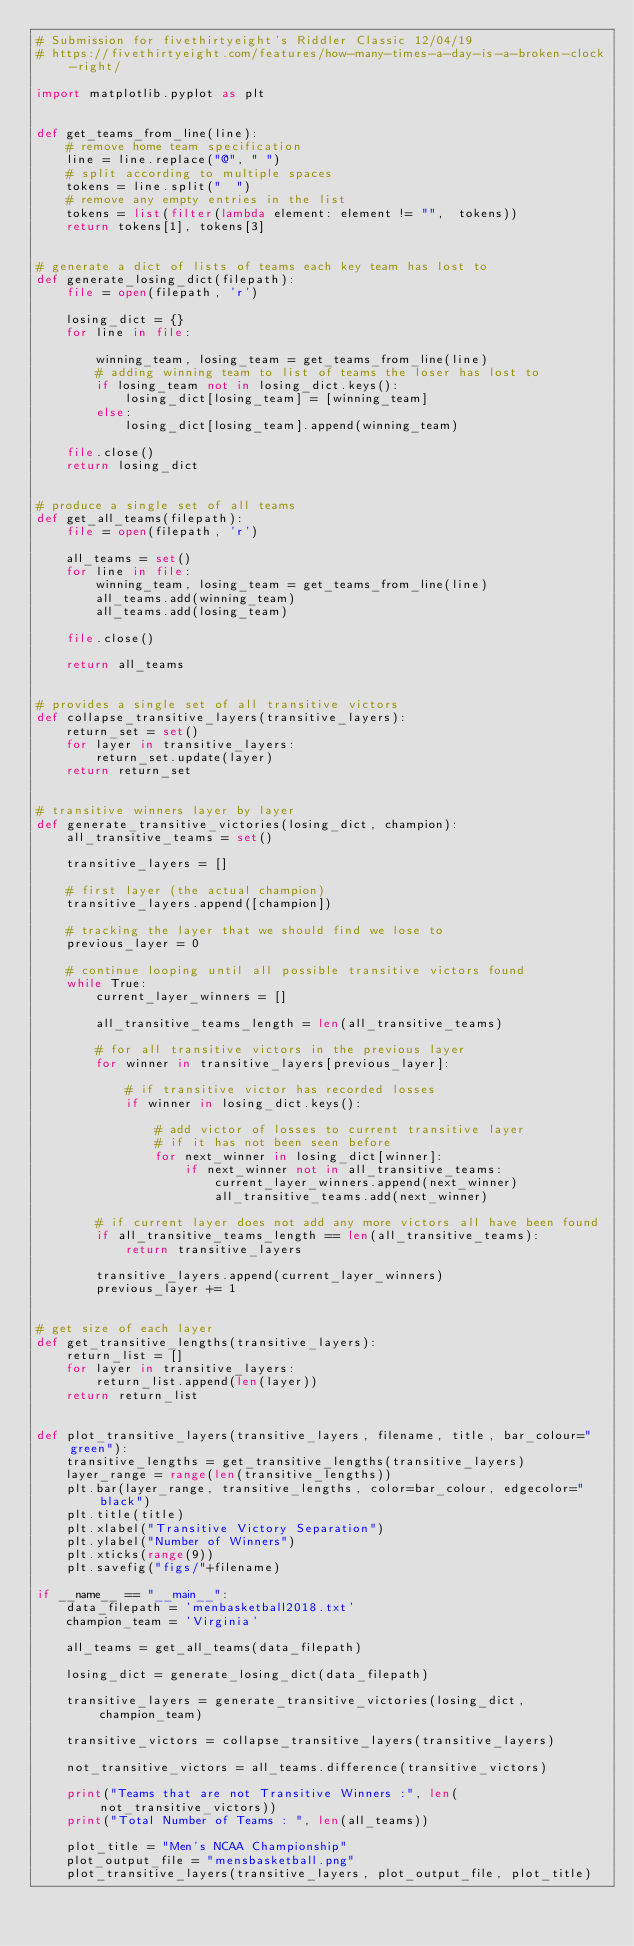Convert code to text. <code><loc_0><loc_0><loc_500><loc_500><_Python_># Submission for fivethirtyeight's Riddler Classic 12/04/19
# https://fivethirtyeight.com/features/how-many-times-a-day-is-a-broken-clock-right/

import matplotlib.pyplot as plt


def get_teams_from_line(line):
    # remove home team specification
    line = line.replace("@", " ")
    # split according to multiple spaces
    tokens = line.split("  ")
    # remove any empty entries in the list
    tokens = list(filter(lambda element: element != "",  tokens))
    return tokens[1], tokens[3]


# generate a dict of lists of teams each key team has lost to
def generate_losing_dict(filepath):
    file = open(filepath, 'r')

    losing_dict = {}
    for line in file:

        winning_team, losing_team = get_teams_from_line(line)
        # adding winning team to list of teams the loser has lost to
        if losing_team not in losing_dict.keys():
            losing_dict[losing_team] = [winning_team]
        else:
            losing_dict[losing_team].append(winning_team)

    file.close()
    return losing_dict


# produce a single set of all teams
def get_all_teams(filepath):
    file = open(filepath, 'r')

    all_teams = set()
    for line in file:
        winning_team, losing_team = get_teams_from_line(line)
        all_teams.add(winning_team)
        all_teams.add(losing_team)

    file.close()

    return all_teams


# provides a single set of all transitive victors
def collapse_transitive_layers(transitive_layers):
    return_set = set()
    for layer in transitive_layers:
        return_set.update(layer)
    return return_set


# transitive winners layer by layer
def generate_transitive_victories(losing_dict, champion):
    all_transitive_teams = set()

    transitive_layers = []

    # first layer (the actual champion)
    transitive_layers.append([champion])

    # tracking the layer that we should find we lose to
    previous_layer = 0

    # continue looping until all possible transitive victors found
    while True:
        current_layer_winners = []

        all_transitive_teams_length = len(all_transitive_teams)

        # for all transitive victors in the previous layer
        for winner in transitive_layers[previous_layer]:

            # if transitive victor has recorded losses
            if winner in losing_dict.keys():

                # add victor of losses to current transitive layer
                # if it has not been seen before
                for next_winner in losing_dict[winner]:
                    if next_winner not in all_transitive_teams:
                        current_layer_winners.append(next_winner)
                        all_transitive_teams.add(next_winner)

        # if current layer does not add any more victors all have been found
        if all_transitive_teams_length == len(all_transitive_teams):
            return transitive_layers

        transitive_layers.append(current_layer_winners)
        previous_layer += 1


# get size of each layer
def get_transitive_lengths(transitive_layers):
    return_list = []
    for layer in transitive_layers:
        return_list.append(len(layer))
    return return_list


def plot_transitive_layers(transitive_layers, filename, title, bar_colour="green"):
    transitive_lengths = get_transitive_lengths(transitive_layers)
    layer_range = range(len(transitive_lengths))
    plt.bar(layer_range, transitive_lengths, color=bar_colour, edgecolor="black")
    plt.title(title)
    plt.xlabel("Transitive Victory Separation")
    plt.ylabel("Number of Winners")
    plt.xticks(range(9))
    plt.savefig("figs/"+filename)

if __name__ == "__main__":
    data_filepath = 'menbasketball2018.txt'
    champion_team = 'Virginia'

    all_teams = get_all_teams(data_filepath)

    losing_dict = generate_losing_dict(data_filepath)

    transitive_layers = generate_transitive_victories(losing_dict, champion_team)

    transitive_victors = collapse_transitive_layers(transitive_layers)

    not_transitive_victors = all_teams.difference(transitive_victors)

    print("Teams that are not Transitive Winners :", len(not_transitive_victors))
    print("Total Number of Teams : ", len(all_teams))

    plot_title = "Men's NCAA Championship"
    plot_output_file = "mensbasketball.png"
    plot_transitive_layers(transitive_layers, plot_output_file, plot_title)
</code> 